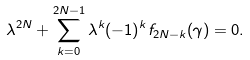Convert formula to latex. <formula><loc_0><loc_0><loc_500><loc_500>\lambda ^ { 2 N } + \sum _ { k = 0 } ^ { 2 N - 1 } \lambda ^ { k } ( - 1 ) ^ { k } f _ { 2 N - k } ( \gamma ) = 0 .</formula> 